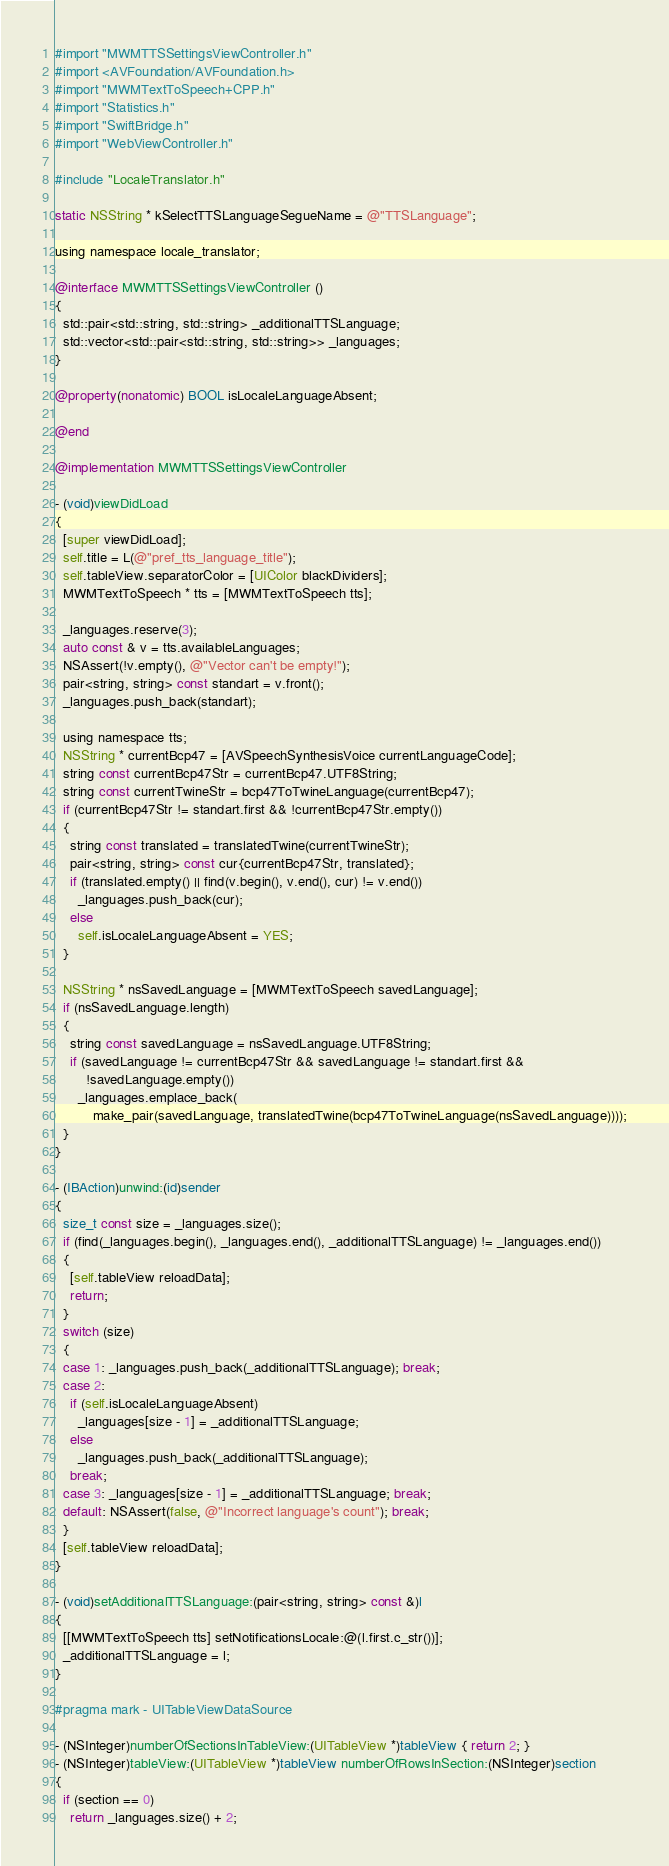<code> <loc_0><loc_0><loc_500><loc_500><_ObjectiveC_>#import "MWMTTSSettingsViewController.h"
#import <AVFoundation/AVFoundation.h>
#import "MWMTextToSpeech+CPP.h"
#import "Statistics.h"
#import "SwiftBridge.h"
#import "WebViewController.h"

#include "LocaleTranslator.h"

static NSString * kSelectTTSLanguageSegueName = @"TTSLanguage";

using namespace locale_translator;

@interface MWMTTSSettingsViewController ()
{
  std::pair<std::string, std::string> _additionalTTSLanguage;
  std::vector<std::pair<std::string, std::string>> _languages;
}

@property(nonatomic) BOOL isLocaleLanguageAbsent;

@end

@implementation MWMTTSSettingsViewController

- (void)viewDidLoad
{
  [super viewDidLoad];
  self.title = L(@"pref_tts_language_title");
  self.tableView.separatorColor = [UIColor blackDividers];
  MWMTextToSpeech * tts = [MWMTextToSpeech tts];

  _languages.reserve(3);
  auto const & v = tts.availableLanguages;
  NSAssert(!v.empty(), @"Vector can't be empty!");
  pair<string, string> const standart = v.front();
  _languages.push_back(standart);

  using namespace tts;
  NSString * currentBcp47 = [AVSpeechSynthesisVoice currentLanguageCode];
  string const currentBcp47Str = currentBcp47.UTF8String;
  string const currentTwineStr = bcp47ToTwineLanguage(currentBcp47);
  if (currentBcp47Str != standart.first && !currentBcp47Str.empty())
  {
    string const translated = translatedTwine(currentTwineStr);
    pair<string, string> const cur{currentBcp47Str, translated};
    if (translated.empty() || find(v.begin(), v.end(), cur) != v.end())
      _languages.push_back(cur);
    else
      self.isLocaleLanguageAbsent = YES;
  }

  NSString * nsSavedLanguage = [MWMTextToSpeech savedLanguage];
  if (nsSavedLanguage.length)
  {
    string const savedLanguage = nsSavedLanguage.UTF8String;
    if (savedLanguage != currentBcp47Str && savedLanguage != standart.first &&
        !savedLanguage.empty())
      _languages.emplace_back(
          make_pair(savedLanguage, translatedTwine(bcp47ToTwineLanguage(nsSavedLanguage))));
  }
}

- (IBAction)unwind:(id)sender
{
  size_t const size = _languages.size();
  if (find(_languages.begin(), _languages.end(), _additionalTTSLanguage) != _languages.end())
  {
    [self.tableView reloadData];
    return;
  }
  switch (size)
  {
  case 1: _languages.push_back(_additionalTTSLanguage); break;
  case 2:
    if (self.isLocaleLanguageAbsent)
      _languages[size - 1] = _additionalTTSLanguage;
    else
      _languages.push_back(_additionalTTSLanguage);
    break;
  case 3: _languages[size - 1] = _additionalTTSLanguage; break;
  default: NSAssert(false, @"Incorrect language's count"); break;
  }
  [self.tableView reloadData];
}

- (void)setAdditionalTTSLanguage:(pair<string, string> const &)l
{
  [[MWMTextToSpeech tts] setNotificationsLocale:@(l.first.c_str())];
  _additionalTTSLanguage = l;
}

#pragma mark - UITableViewDataSource

- (NSInteger)numberOfSectionsInTableView:(UITableView *)tableView { return 2; }
- (NSInteger)tableView:(UITableView *)tableView numberOfRowsInSection:(NSInteger)section
{
  if (section == 0)
    return _languages.size() + 2;</code> 